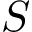<formula> <loc_0><loc_0><loc_500><loc_500>S</formula> 